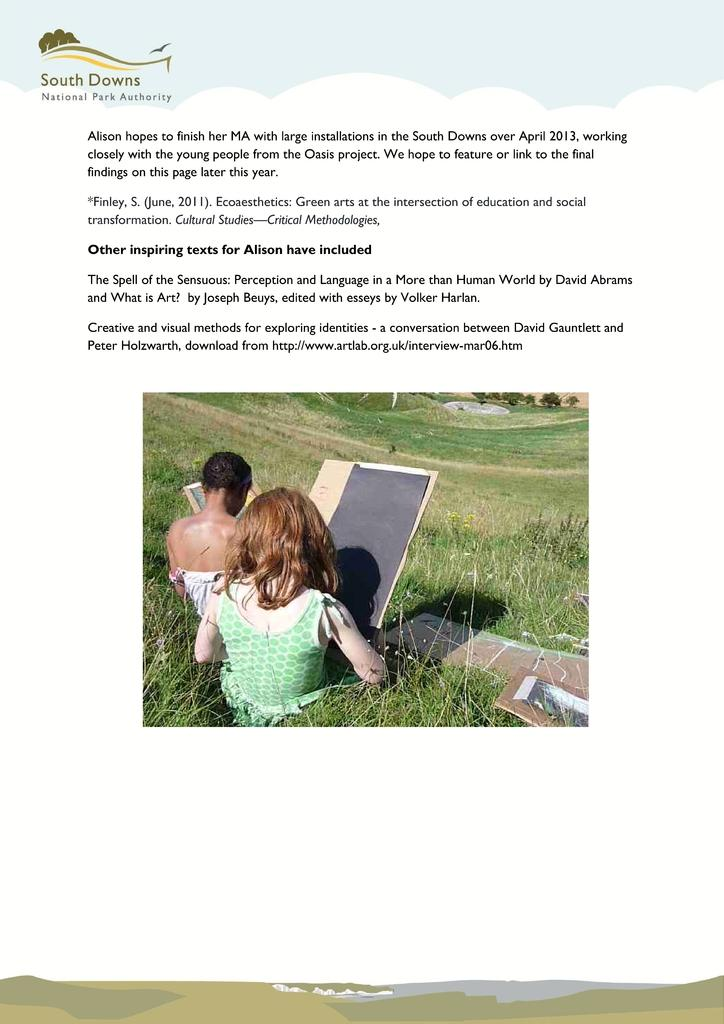What is present in the image that might contain information or writing? There is a paper in the image that might contain information or writing. Where are the two people in the image located? The two people are sitting on the grass in the image. What other objects can be seen in the image? There are cardboards in the image. Can you describe any text visible in the image? Yes, there is text visible in the image. What type of pets are visible in the middle of the image? There are no pets present in the image. How many tramps can be seen in the image? There are no tramps present in the image. 